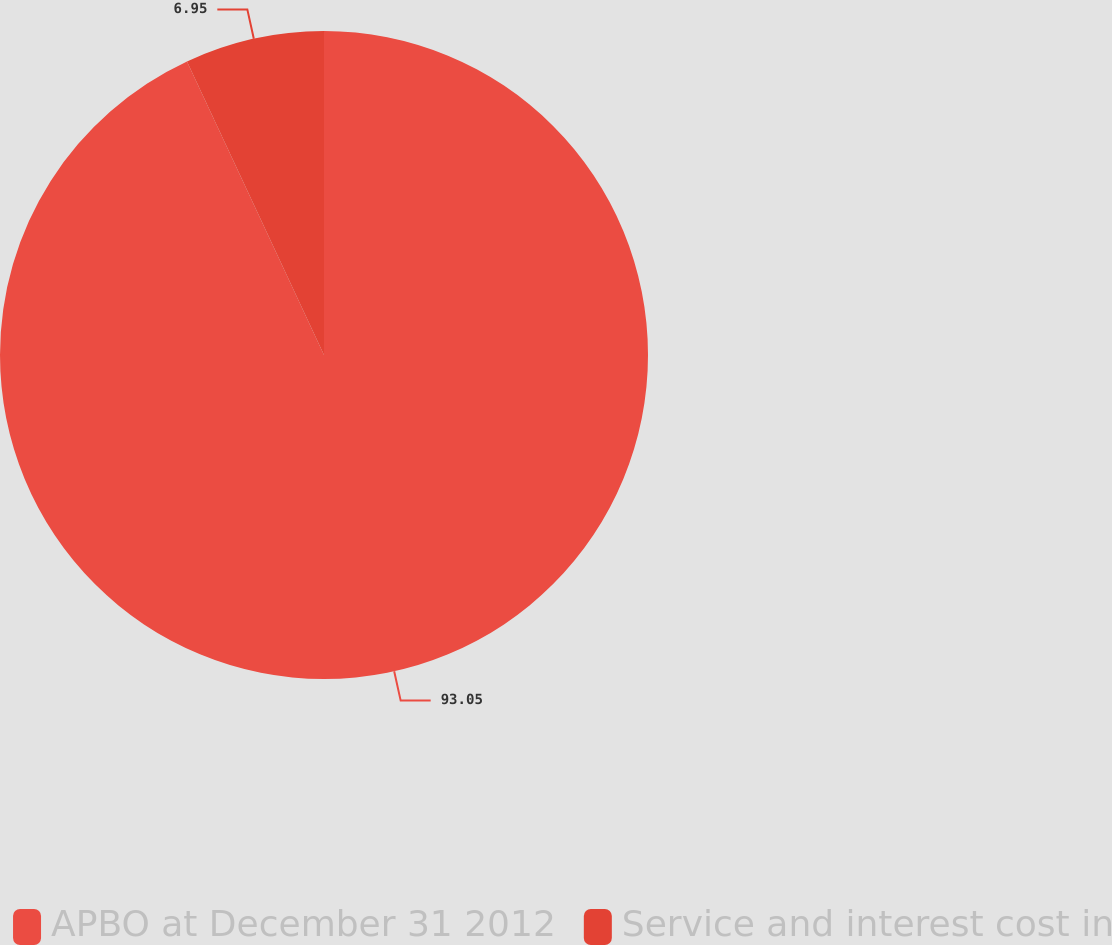Convert chart to OTSL. <chart><loc_0><loc_0><loc_500><loc_500><pie_chart><fcel>APBO at December 31 2012<fcel>Service and interest cost in<nl><fcel>93.05%<fcel>6.95%<nl></chart> 